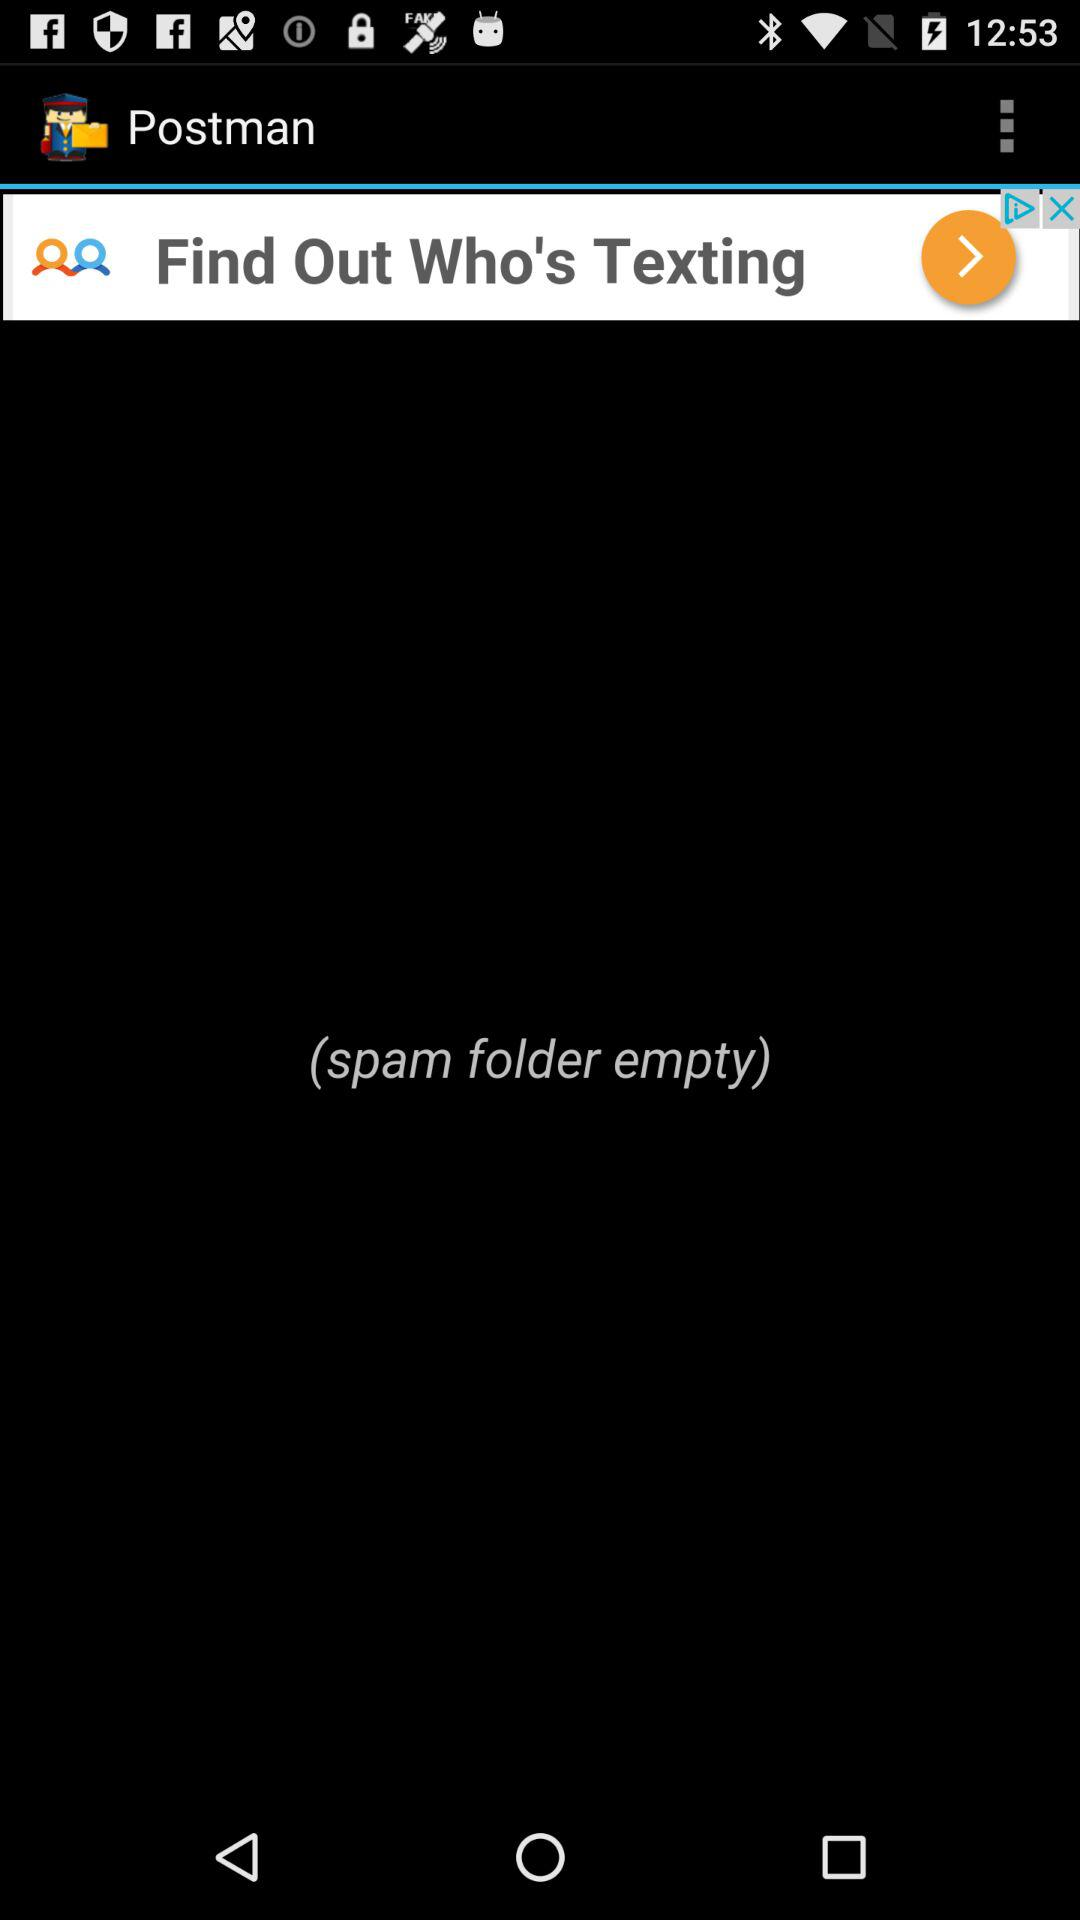Is the inbox empty?
When the provided information is insufficient, respond with <no answer>. <no answer> 